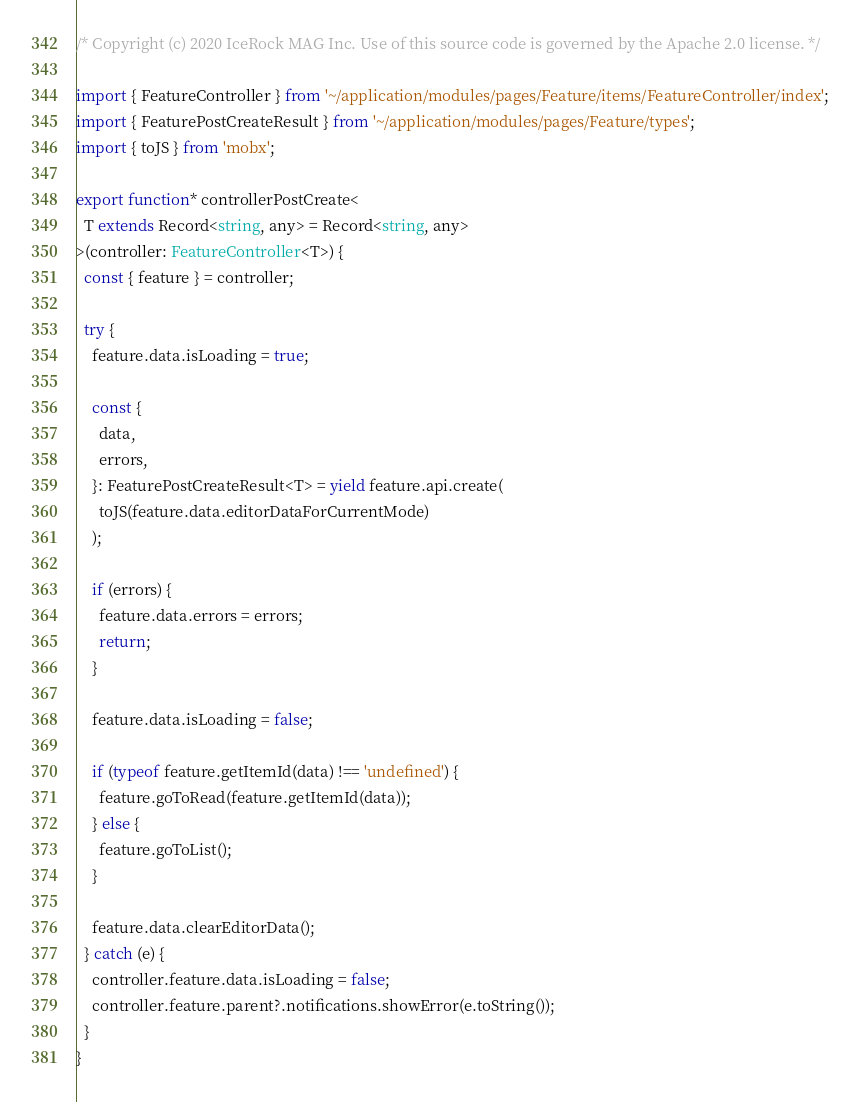<code> <loc_0><loc_0><loc_500><loc_500><_TypeScript_>/* Copyright (c) 2020 IceRock MAG Inc. Use of this source code is governed by the Apache 2.0 license. */

import { FeatureController } from '~/application/modules/pages/Feature/items/FeatureController/index';
import { FeaturePostCreateResult } from '~/application/modules/pages/Feature/types';
import { toJS } from 'mobx';

export function* controllerPostCreate<
  T extends Record<string, any> = Record<string, any>
>(controller: FeatureController<T>) {
  const { feature } = controller;

  try {
    feature.data.isLoading = true;

    const {
      data,
      errors,
    }: FeaturePostCreateResult<T> = yield feature.api.create(
      toJS(feature.data.editorDataForCurrentMode)
    );

    if (errors) {
      feature.data.errors = errors;
      return;
    }

    feature.data.isLoading = false;

    if (typeof feature.getItemId(data) !== 'undefined') {
      feature.goToRead(feature.getItemId(data));
    } else {
      feature.goToList();
    }

    feature.data.clearEditorData();
  } catch (e) {
    controller.feature.data.isLoading = false;
    controller.feature.parent?.notifications.showError(e.toString());
  }
}
</code> 